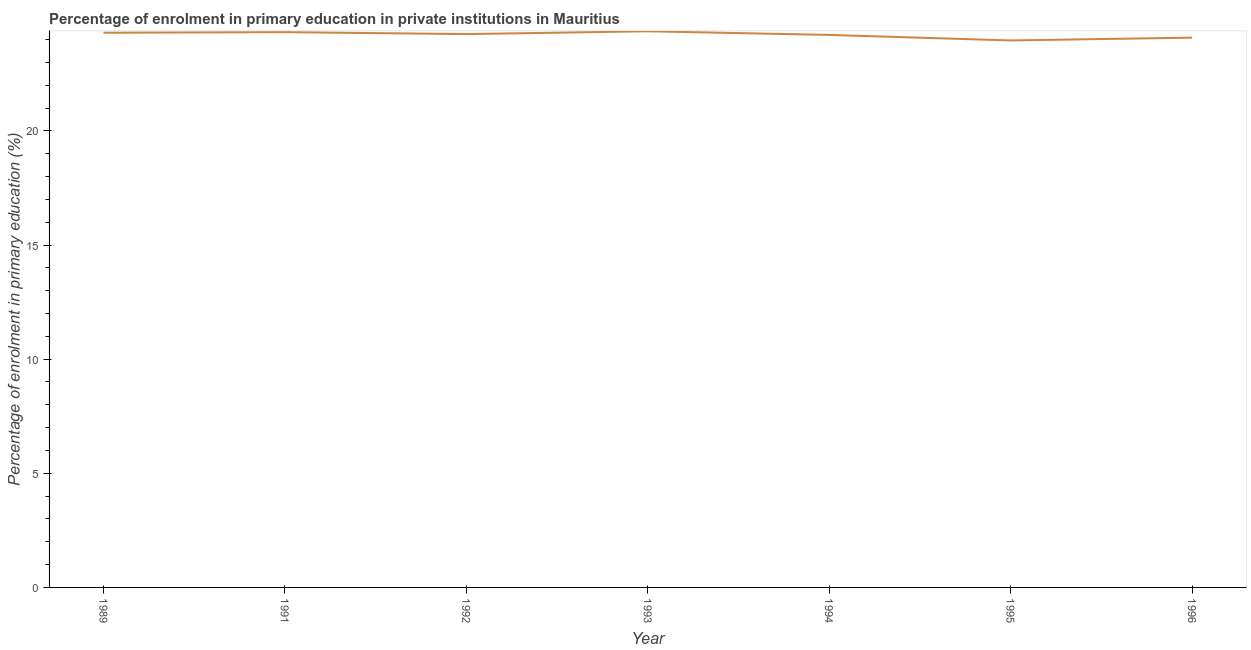What is the enrolment percentage in primary education in 1991?
Offer a terse response. 24.32. Across all years, what is the maximum enrolment percentage in primary education?
Ensure brevity in your answer.  24.36. Across all years, what is the minimum enrolment percentage in primary education?
Provide a succinct answer. 23.96. In which year was the enrolment percentage in primary education maximum?
Your answer should be compact. 1993. What is the sum of the enrolment percentage in primary education?
Ensure brevity in your answer.  169.47. What is the difference between the enrolment percentage in primary education in 1989 and 1993?
Ensure brevity in your answer.  -0.06. What is the average enrolment percentage in primary education per year?
Your response must be concise. 24.21. What is the median enrolment percentage in primary education?
Your response must be concise. 24.24. Do a majority of the years between 1992 and 1991 (inclusive) have enrolment percentage in primary education greater than 4 %?
Offer a very short reply. No. What is the ratio of the enrolment percentage in primary education in 1995 to that in 1996?
Your answer should be compact. 0.99. Is the enrolment percentage in primary education in 1992 less than that in 1996?
Your answer should be compact. No. What is the difference between the highest and the second highest enrolment percentage in primary education?
Offer a terse response. 0.04. What is the difference between the highest and the lowest enrolment percentage in primary education?
Keep it short and to the point. 0.4. Does the enrolment percentage in primary education monotonically increase over the years?
Offer a terse response. No. What is the difference between two consecutive major ticks on the Y-axis?
Your response must be concise. 5. Does the graph contain grids?
Your answer should be compact. No. What is the title of the graph?
Offer a terse response. Percentage of enrolment in primary education in private institutions in Mauritius. What is the label or title of the X-axis?
Provide a short and direct response. Year. What is the label or title of the Y-axis?
Ensure brevity in your answer.  Percentage of enrolment in primary education (%). What is the Percentage of enrolment in primary education (%) in 1989?
Offer a terse response. 24.3. What is the Percentage of enrolment in primary education (%) in 1991?
Your answer should be very brief. 24.32. What is the Percentage of enrolment in primary education (%) in 1992?
Provide a succinct answer. 24.24. What is the Percentage of enrolment in primary education (%) in 1993?
Make the answer very short. 24.36. What is the Percentage of enrolment in primary education (%) in 1994?
Offer a very short reply. 24.2. What is the Percentage of enrolment in primary education (%) of 1995?
Keep it short and to the point. 23.96. What is the Percentage of enrolment in primary education (%) of 1996?
Ensure brevity in your answer.  24.08. What is the difference between the Percentage of enrolment in primary education (%) in 1989 and 1991?
Keep it short and to the point. -0.03. What is the difference between the Percentage of enrolment in primary education (%) in 1989 and 1992?
Your answer should be compact. 0.06. What is the difference between the Percentage of enrolment in primary education (%) in 1989 and 1993?
Ensure brevity in your answer.  -0.06. What is the difference between the Percentage of enrolment in primary education (%) in 1989 and 1994?
Ensure brevity in your answer.  0.1. What is the difference between the Percentage of enrolment in primary education (%) in 1989 and 1995?
Ensure brevity in your answer.  0.34. What is the difference between the Percentage of enrolment in primary education (%) in 1989 and 1996?
Ensure brevity in your answer.  0.21. What is the difference between the Percentage of enrolment in primary education (%) in 1991 and 1992?
Make the answer very short. 0.09. What is the difference between the Percentage of enrolment in primary education (%) in 1991 and 1993?
Offer a terse response. -0.04. What is the difference between the Percentage of enrolment in primary education (%) in 1991 and 1994?
Provide a short and direct response. 0.12. What is the difference between the Percentage of enrolment in primary education (%) in 1991 and 1995?
Ensure brevity in your answer.  0.36. What is the difference between the Percentage of enrolment in primary education (%) in 1991 and 1996?
Make the answer very short. 0.24. What is the difference between the Percentage of enrolment in primary education (%) in 1992 and 1993?
Your answer should be compact. -0.12. What is the difference between the Percentage of enrolment in primary education (%) in 1992 and 1994?
Give a very brief answer. 0.04. What is the difference between the Percentage of enrolment in primary education (%) in 1992 and 1995?
Provide a short and direct response. 0.28. What is the difference between the Percentage of enrolment in primary education (%) in 1992 and 1996?
Ensure brevity in your answer.  0.15. What is the difference between the Percentage of enrolment in primary education (%) in 1993 and 1994?
Your response must be concise. 0.16. What is the difference between the Percentage of enrolment in primary education (%) in 1993 and 1995?
Your answer should be very brief. 0.4. What is the difference between the Percentage of enrolment in primary education (%) in 1993 and 1996?
Your response must be concise. 0.28. What is the difference between the Percentage of enrolment in primary education (%) in 1994 and 1995?
Give a very brief answer. 0.24. What is the difference between the Percentage of enrolment in primary education (%) in 1994 and 1996?
Provide a succinct answer. 0.12. What is the difference between the Percentage of enrolment in primary education (%) in 1995 and 1996?
Your response must be concise. -0.12. What is the ratio of the Percentage of enrolment in primary education (%) in 1989 to that in 1991?
Make the answer very short. 1. What is the ratio of the Percentage of enrolment in primary education (%) in 1989 to that in 1992?
Give a very brief answer. 1. What is the ratio of the Percentage of enrolment in primary education (%) in 1989 to that in 1993?
Make the answer very short. 1. What is the ratio of the Percentage of enrolment in primary education (%) in 1989 to that in 1995?
Provide a short and direct response. 1.01. What is the ratio of the Percentage of enrolment in primary education (%) in 1991 to that in 1993?
Your answer should be compact. 1. What is the ratio of the Percentage of enrolment in primary education (%) in 1992 to that in 1994?
Offer a terse response. 1. What is the ratio of the Percentage of enrolment in primary education (%) in 1993 to that in 1994?
Ensure brevity in your answer.  1.01. What is the ratio of the Percentage of enrolment in primary education (%) in 1993 to that in 1995?
Your answer should be very brief. 1.02. What is the ratio of the Percentage of enrolment in primary education (%) in 1993 to that in 1996?
Offer a terse response. 1.01. What is the ratio of the Percentage of enrolment in primary education (%) in 1994 to that in 1995?
Keep it short and to the point. 1.01. What is the ratio of the Percentage of enrolment in primary education (%) in 1994 to that in 1996?
Your response must be concise. 1. 